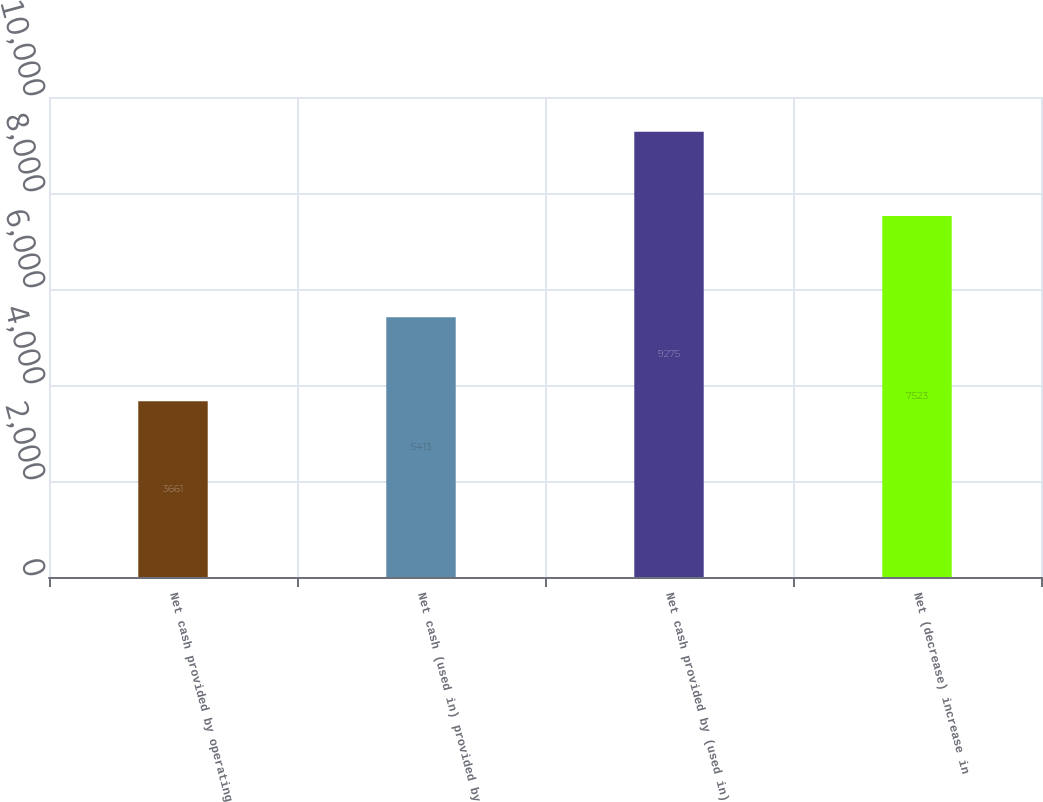<chart> <loc_0><loc_0><loc_500><loc_500><bar_chart><fcel>Net cash provided by operating<fcel>Net cash (used in) provided by<fcel>Net cash provided by (used in)<fcel>Net (decrease) increase in<nl><fcel>3661<fcel>5413<fcel>9275<fcel>7523<nl></chart> 